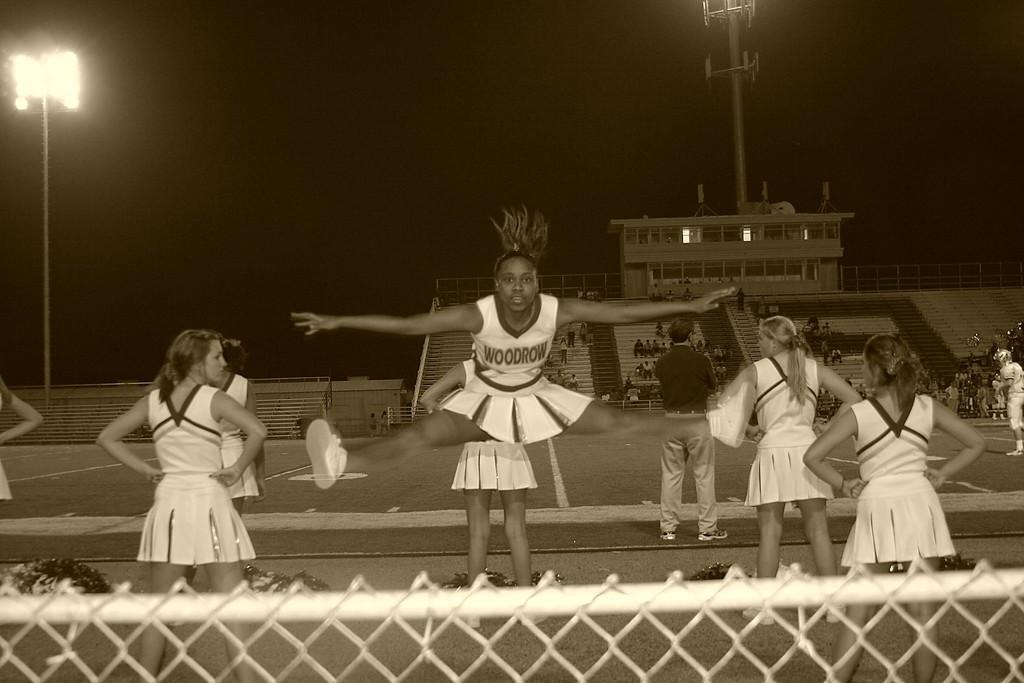How would you summarize this image in a sentence or two? In the foreground of this black and white image, there is a woman in the air and remaining are standing. On the bottom, there is the fencing. In the background, there are persons sitting on the stairs, a building, poles and the dark sky. 